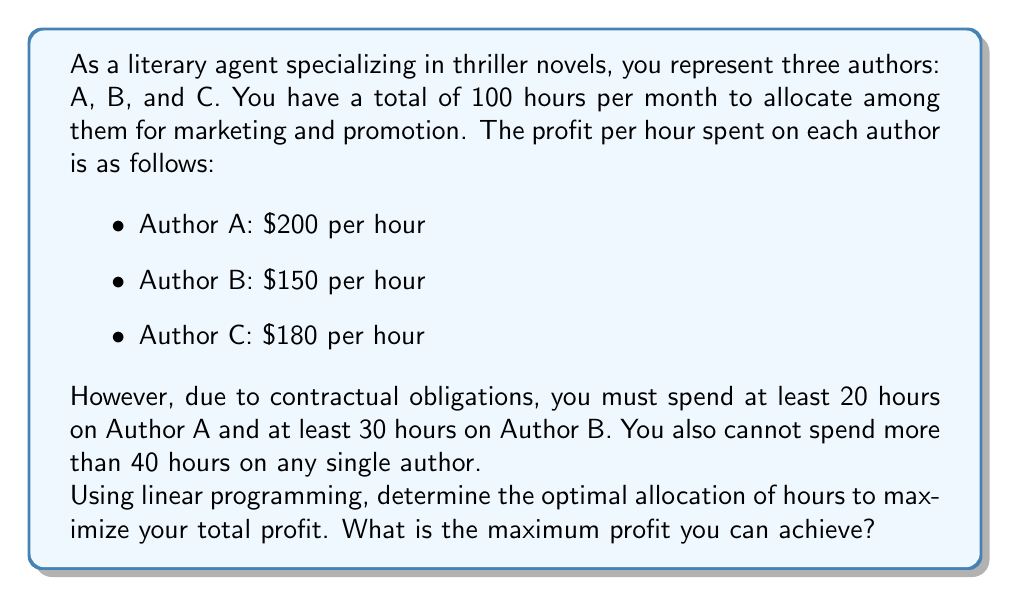Teach me how to tackle this problem. To solve this problem using linear programming, we need to:

1. Define variables
2. Set up the objective function
3. Identify constraints
4. Solve the linear programming problem

Step 1: Define variables
Let $x_A$, $x_B$, and $x_C$ be the number of hours allocated to Authors A, B, and C, respectively.

Step 2: Set up the objective function
The objective is to maximize profit:

$$\text{Maximize } Z = 200x_A + 150x_B + 180x_C$$

Step 3: Identify constraints

a) Total hours constraint:
   $$x_A + x_B + x_C \leq 100$$

b) Minimum hours for Author A:
   $$x_A \geq 20$$

c) Minimum hours for Author B:
   $$x_B \geq 30$$

d) Maximum hours for each author:
   $$x_A \leq 40$$
   $$x_B \leq 40$$
   $$x_C \leq 40$$

e) Non-negativity constraints:
   $$x_A, x_B, x_C \geq 0$$

Step 4: Solve the linear programming problem

We can solve this problem using the simplex method or a linear programming solver. The optimal solution is:

$$x_A = 30$$
$$x_B = 30$$
$$x_C = 40$$

To verify this solution:
1. It satisfies all constraints.
2. We cannot increase any variable without violating a constraint.
3. Any other feasible solution would result in lower total profit.

The maximum profit can be calculated by plugging these values into the objective function:

$$Z = 200(30) + 150(30) + 180(40) = 6000 + 4500 + 7200 = 17700$$

Therefore, the maximum profit that can be achieved is $17,700.
Answer: $17,700 